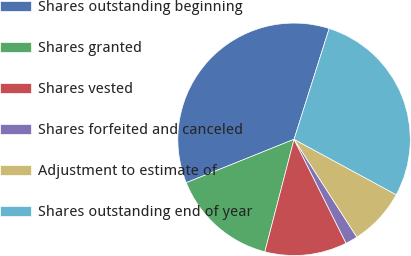Convert chart. <chart><loc_0><loc_0><loc_500><loc_500><pie_chart><fcel>Shares outstanding beginning<fcel>Shares granted<fcel>Shares vested<fcel>Shares forfeited and canceled<fcel>Adjustment to estimate of<fcel>Shares outstanding end of year<nl><fcel>35.98%<fcel>14.86%<fcel>11.43%<fcel>1.7%<fcel>8.0%<fcel>28.03%<nl></chart> 